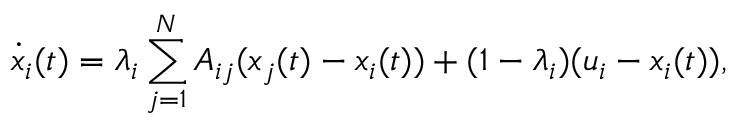<formula> <loc_0><loc_0><loc_500><loc_500>\dot { x } _ { i } ( t ) = \lambda _ { i } \sum _ { j = 1 } ^ { N } A _ { i j } ( x _ { j } ( t ) - x _ { i } ( t ) ) + ( 1 - \lambda _ { i } ) ( u _ { i } - x _ { i } ( t ) ) ,</formula> 